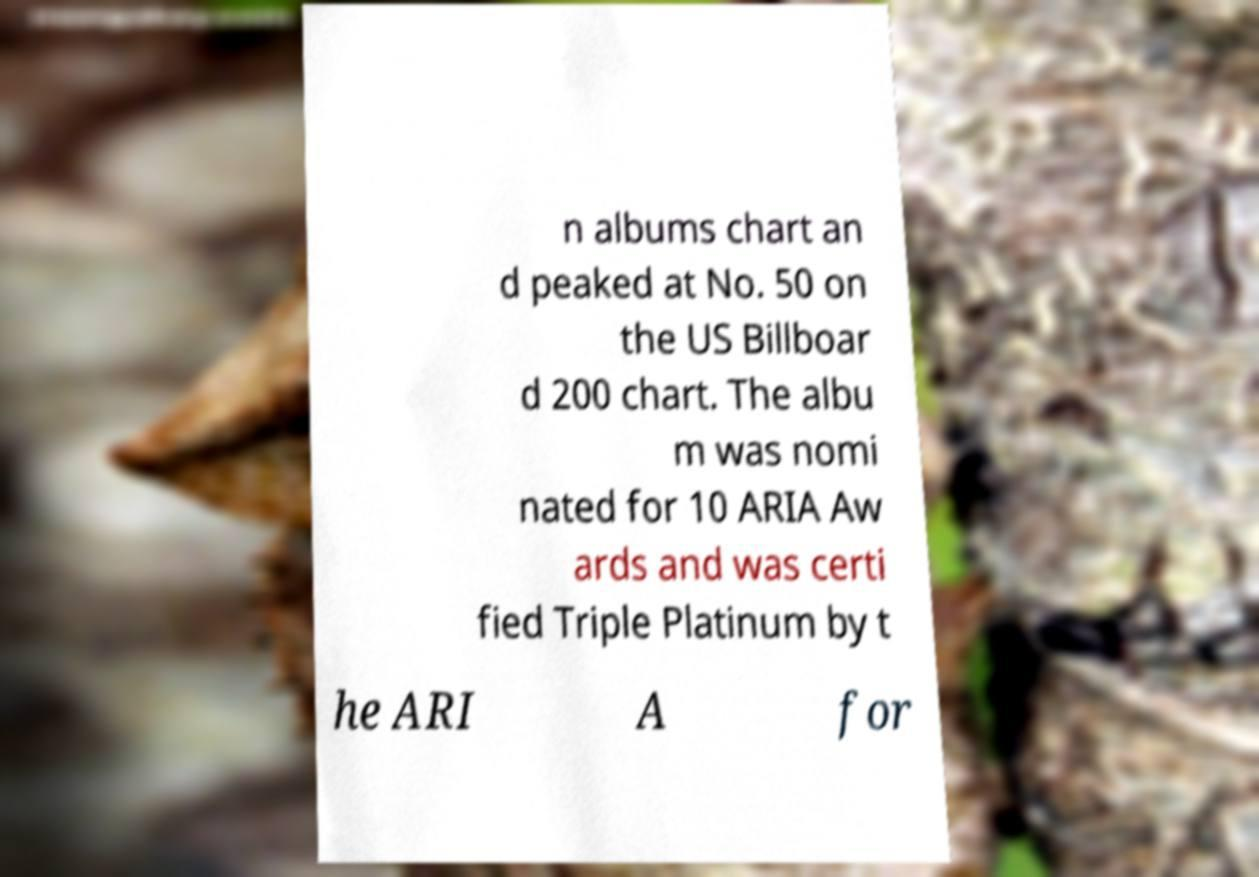Please read and relay the text visible in this image. What does it say? n albums chart an d peaked at No. 50 on the US Billboar d 200 chart. The albu m was nomi nated for 10 ARIA Aw ards and was certi fied Triple Platinum by t he ARI A for 